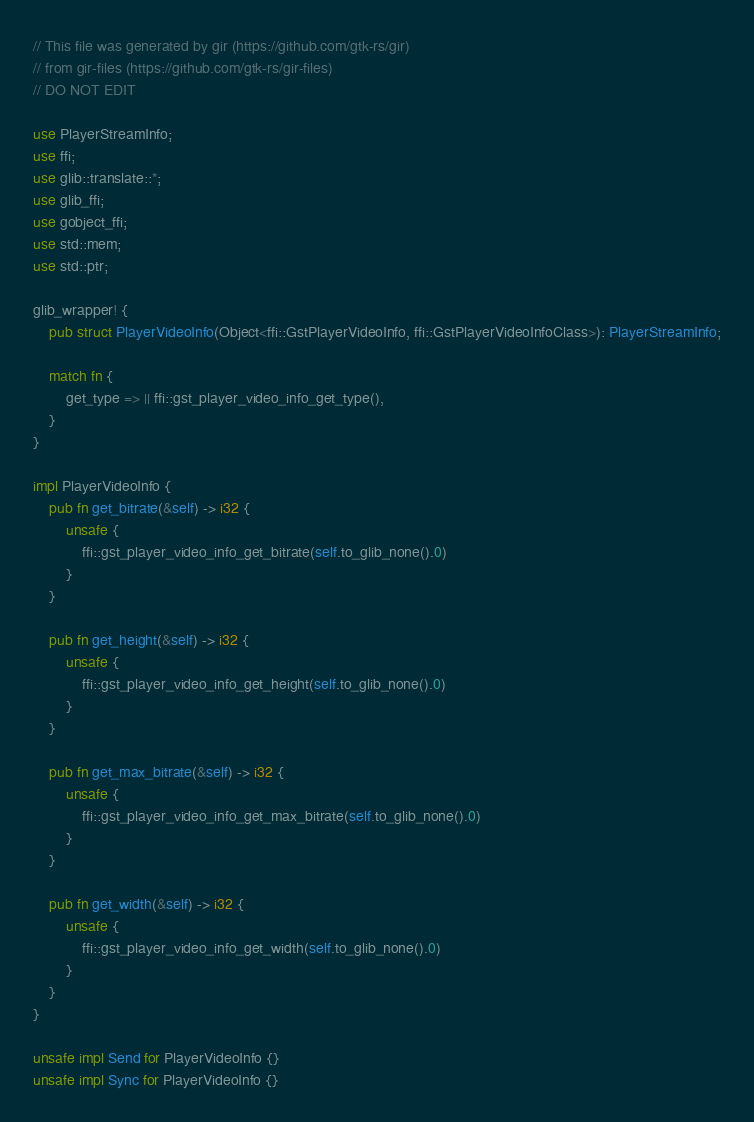Convert code to text. <code><loc_0><loc_0><loc_500><loc_500><_Rust_>// This file was generated by gir (https://github.com/gtk-rs/gir)
// from gir-files (https://github.com/gtk-rs/gir-files)
// DO NOT EDIT

use PlayerStreamInfo;
use ffi;
use glib::translate::*;
use glib_ffi;
use gobject_ffi;
use std::mem;
use std::ptr;

glib_wrapper! {
    pub struct PlayerVideoInfo(Object<ffi::GstPlayerVideoInfo, ffi::GstPlayerVideoInfoClass>): PlayerStreamInfo;

    match fn {
        get_type => || ffi::gst_player_video_info_get_type(),
    }
}

impl PlayerVideoInfo {
    pub fn get_bitrate(&self) -> i32 {
        unsafe {
            ffi::gst_player_video_info_get_bitrate(self.to_glib_none().0)
        }
    }

    pub fn get_height(&self) -> i32 {
        unsafe {
            ffi::gst_player_video_info_get_height(self.to_glib_none().0)
        }
    }

    pub fn get_max_bitrate(&self) -> i32 {
        unsafe {
            ffi::gst_player_video_info_get_max_bitrate(self.to_glib_none().0)
        }
    }

    pub fn get_width(&self) -> i32 {
        unsafe {
            ffi::gst_player_video_info_get_width(self.to_glib_none().0)
        }
    }
}

unsafe impl Send for PlayerVideoInfo {}
unsafe impl Sync for PlayerVideoInfo {}
</code> 